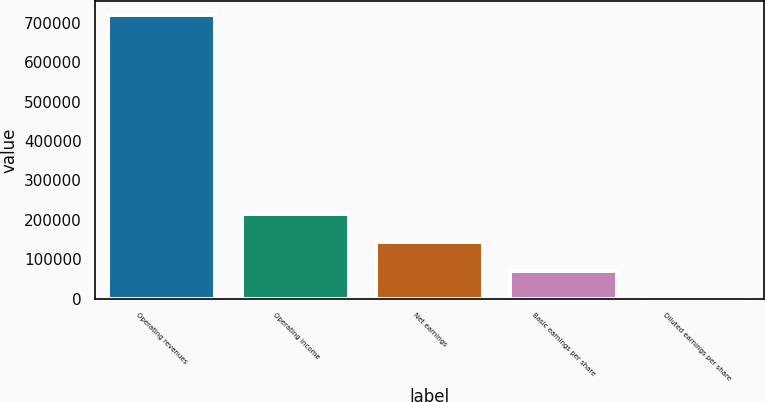<chart> <loc_0><loc_0><loc_500><loc_500><bar_chart><fcel>Operating revenues<fcel>Operating income<fcel>Net earnings<fcel>Basic earnings per share<fcel>Diluted earnings per share<nl><fcel>718614<fcel>215585<fcel>143723<fcel>71861.9<fcel>0.57<nl></chart> 